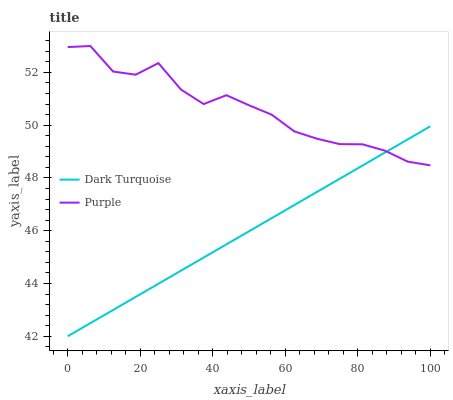Does Dark Turquoise have the minimum area under the curve?
Answer yes or no. Yes. Does Purple have the maximum area under the curve?
Answer yes or no. Yes. Does Dark Turquoise have the maximum area under the curve?
Answer yes or no. No. Is Dark Turquoise the smoothest?
Answer yes or no. Yes. Is Purple the roughest?
Answer yes or no. Yes. Is Dark Turquoise the roughest?
Answer yes or no. No. Does Dark Turquoise have the lowest value?
Answer yes or no. Yes. Does Purple have the highest value?
Answer yes or no. Yes. Does Dark Turquoise have the highest value?
Answer yes or no. No. Does Purple intersect Dark Turquoise?
Answer yes or no. Yes. Is Purple less than Dark Turquoise?
Answer yes or no. No. Is Purple greater than Dark Turquoise?
Answer yes or no. No. 